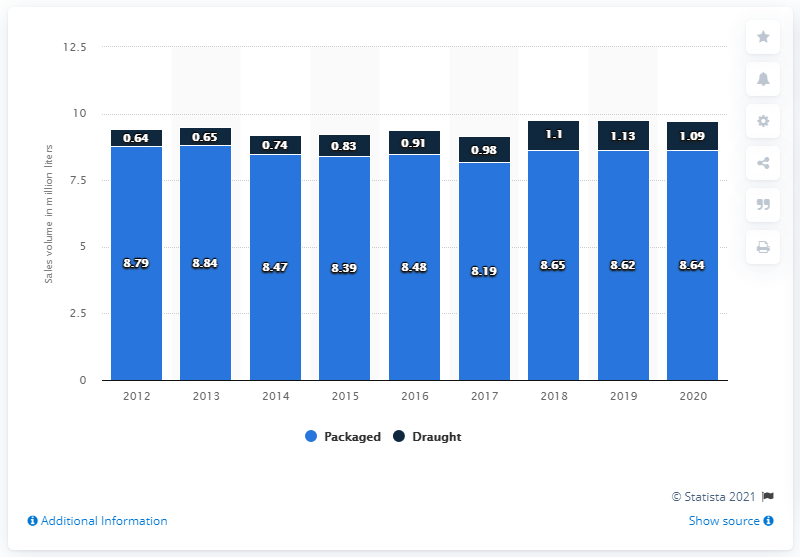Highlight a few significant elements in this photo. The sales volume of packaged beer in Prince Edward Island in the previous year was 8.64 million liters. In the fiscal year 2020, the sales volume of packaged beer in P.E.I was 8.64 million liters. 